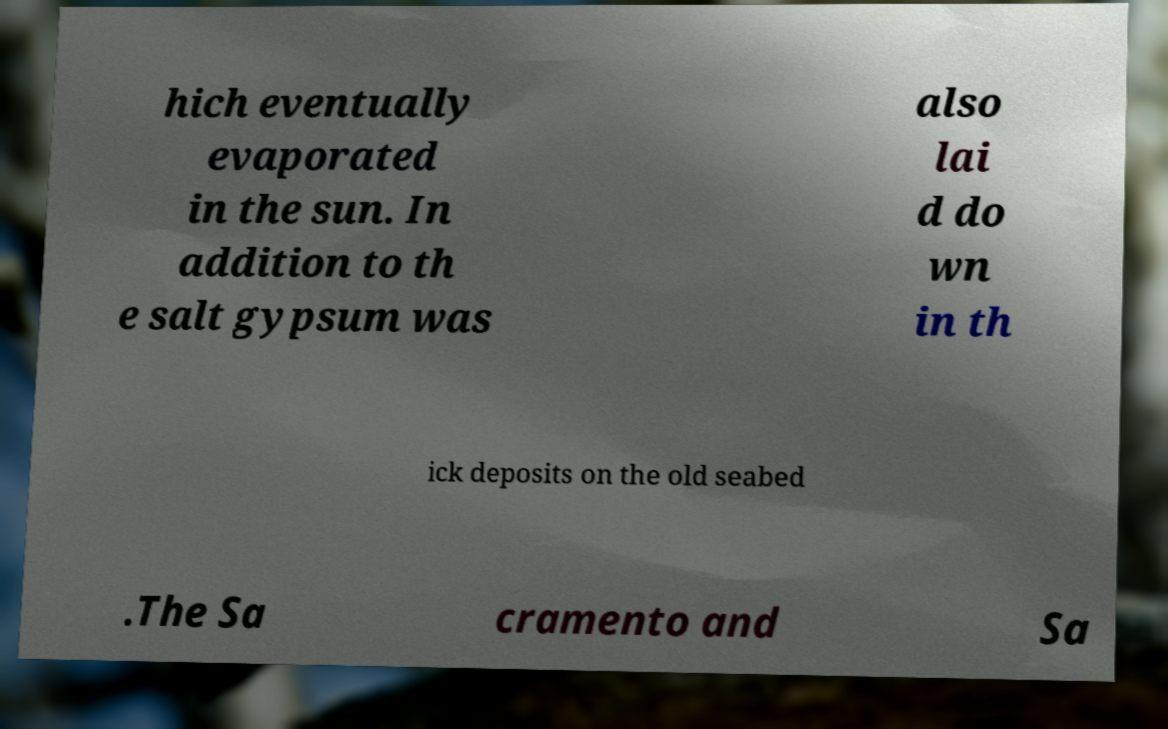Could you extract and type out the text from this image? hich eventually evaporated in the sun. In addition to th e salt gypsum was also lai d do wn in th ick deposits on the old seabed .The Sa cramento and Sa 